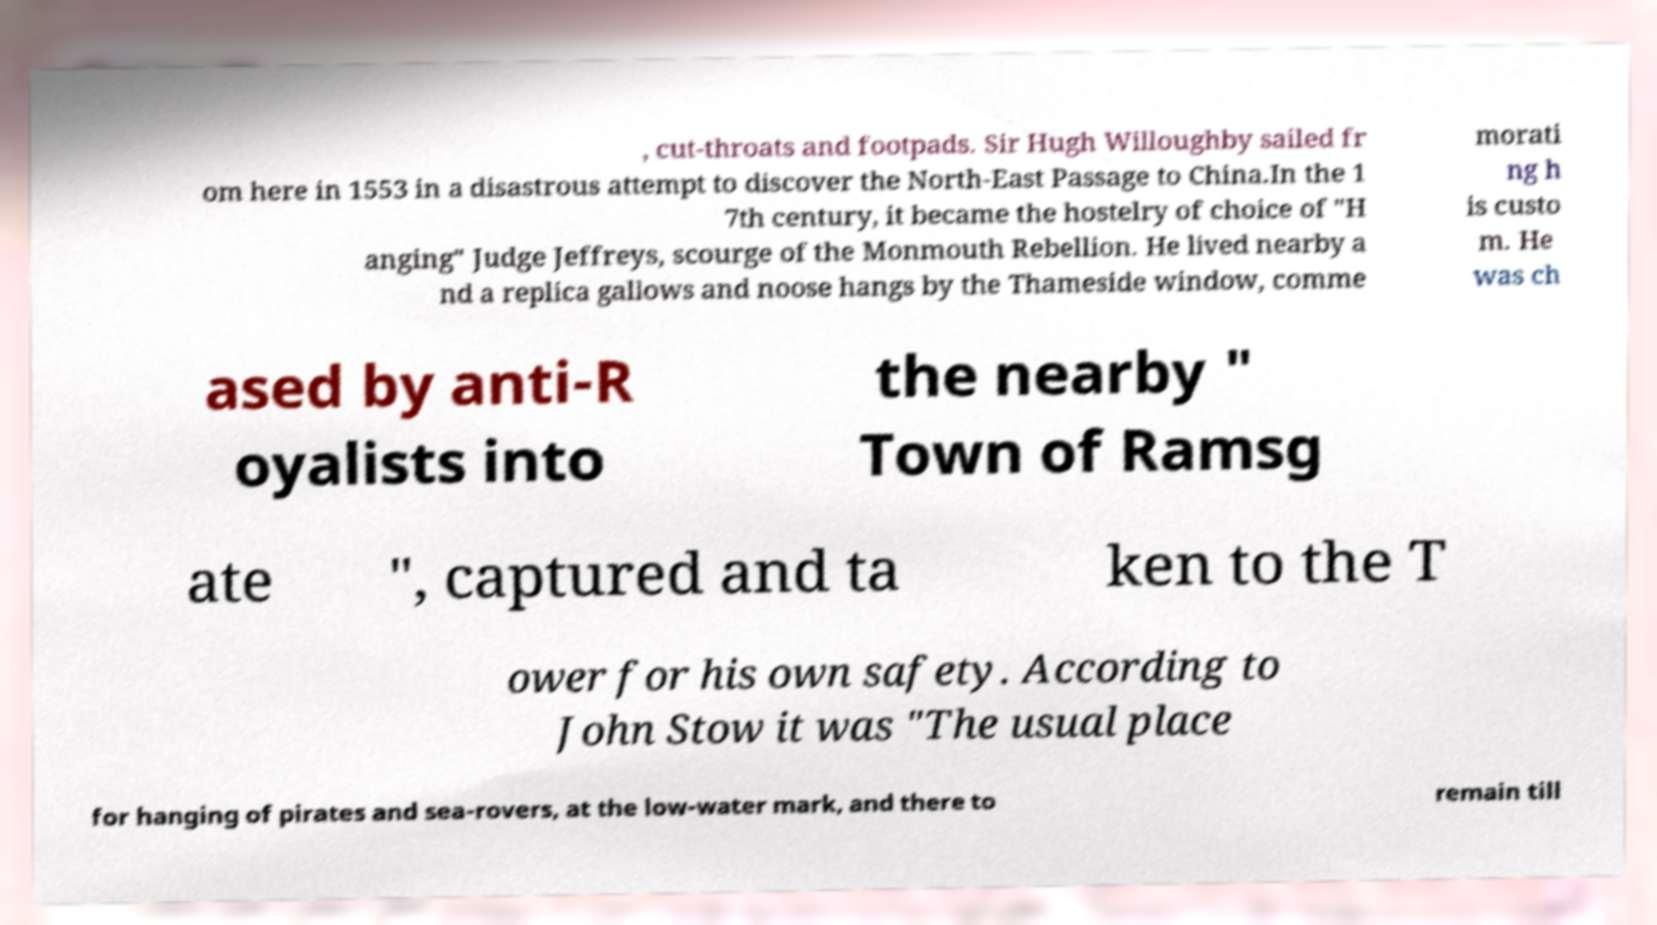Please read and relay the text visible in this image. What does it say? , cut-throats and footpads. Sir Hugh Willoughby sailed fr om here in 1553 in a disastrous attempt to discover the North-East Passage to China.In the 1 7th century, it became the hostelry of choice of "H anging" Judge Jeffreys, scourge of the Monmouth Rebellion. He lived nearby a nd a replica gallows and noose hangs by the Thameside window, comme morati ng h is custo m. He was ch ased by anti-R oyalists into the nearby " Town of Ramsg ate ", captured and ta ken to the T ower for his own safety. According to John Stow it was "The usual place for hanging of pirates and sea-rovers, at the low-water mark, and there to remain till 